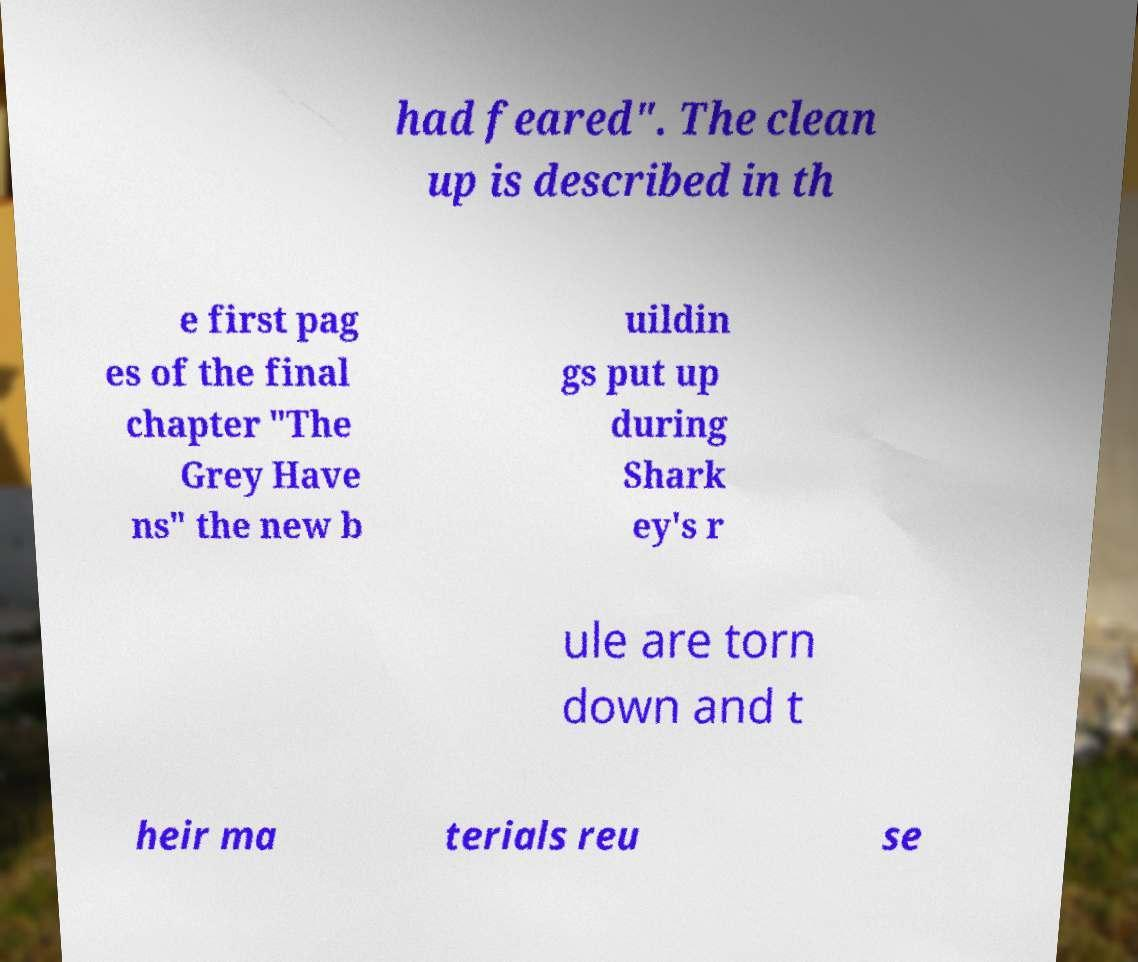Can you read and provide the text displayed in the image?This photo seems to have some interesting text. Can you extract and type it out for me? had feared". The clean up is described in th e first pag es of the final chapter "The Grey Have ns" the new b uildin gs put up during Shark ey's r ule are torn down and t heir ma terials reu se 